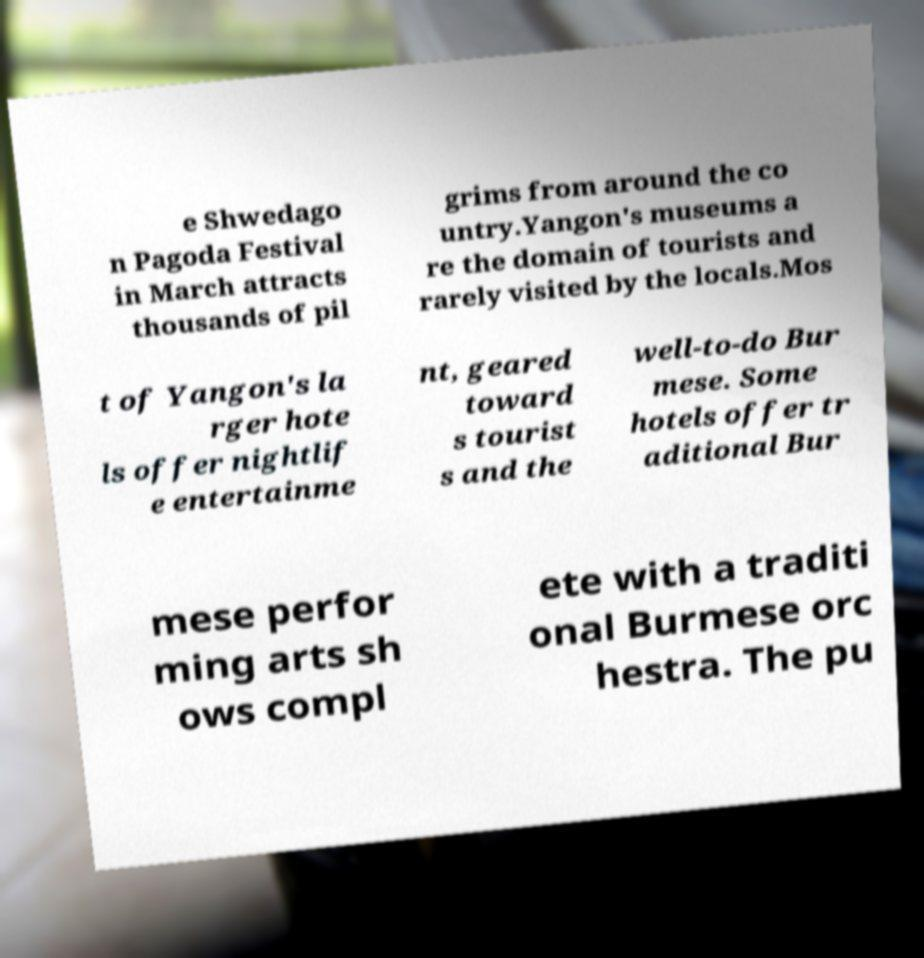I need the written content from this picture converted into text. Can you do that? e Shwedago n Pagoda Festival in March attracts thousands of pil grims from around the co untry.Yangon's museums a re the domain of tourists and rarely visited by the locals.Mos t of Yangon's la rger hote ls offer nightlif e entertainme nt, geared toward s tourist s and the well-to-do Bur mese. Some hotels offer tr aditional Bur mese perfor ming arts sh ows compl ete with a traditi onal Burmese orc hestra. The pu 